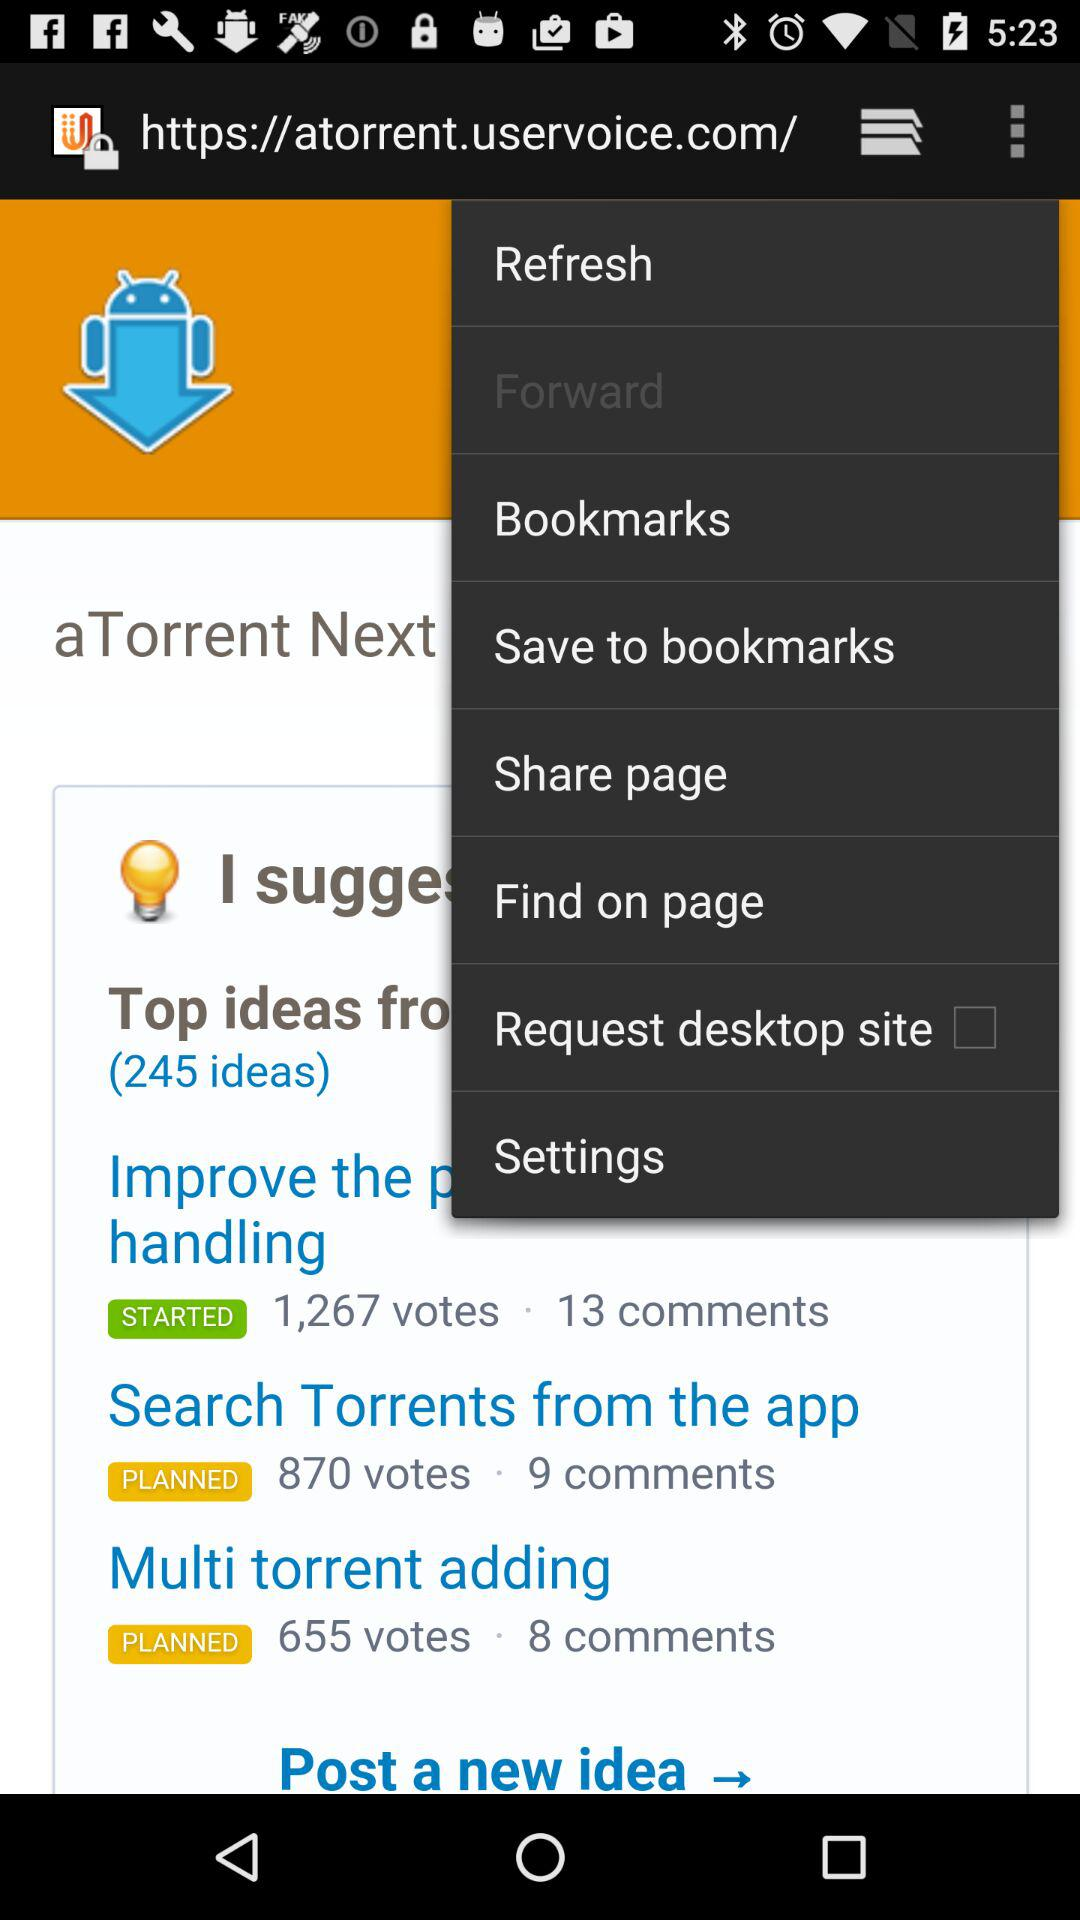How many more votes does the top idea have than the third idea?
Answer the question using a single word or phrase. 612 